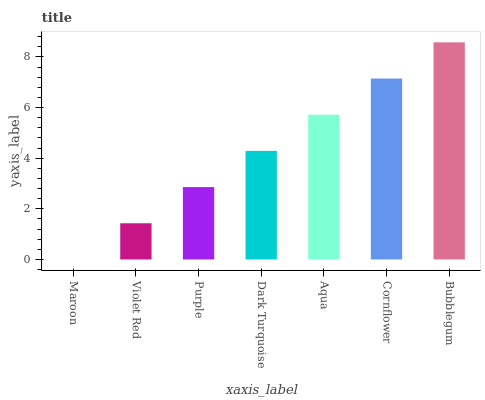Is Maroon the minimum?
Answer yes or no. Yes. Is Bubblegum the maximum?
Answer yes or no. Yes. Is Violet Red the minimum?
Answer yes or no. No. Is Violet Red the maximum?
Answer yes or no. No. Is Violet Red greater than Maroon?
Answer yes or no. Yes. Is Maroon less than Violet Red?
Answer yes or no. Yes. Is Maroon greater than Violet Red?
Answer yes or no. No. Is Violet Red less than Maroon?
Answer yes or no. No. Is Dark Turquoise the high median?
Answer yes or no. Yes. Is Dark Turquoise the low median?
Answer yes or no. Yes. Is Aqua the high median?
Answer yes or no. No. Is Bubblegum the low median?
Answer yes or no. No. 